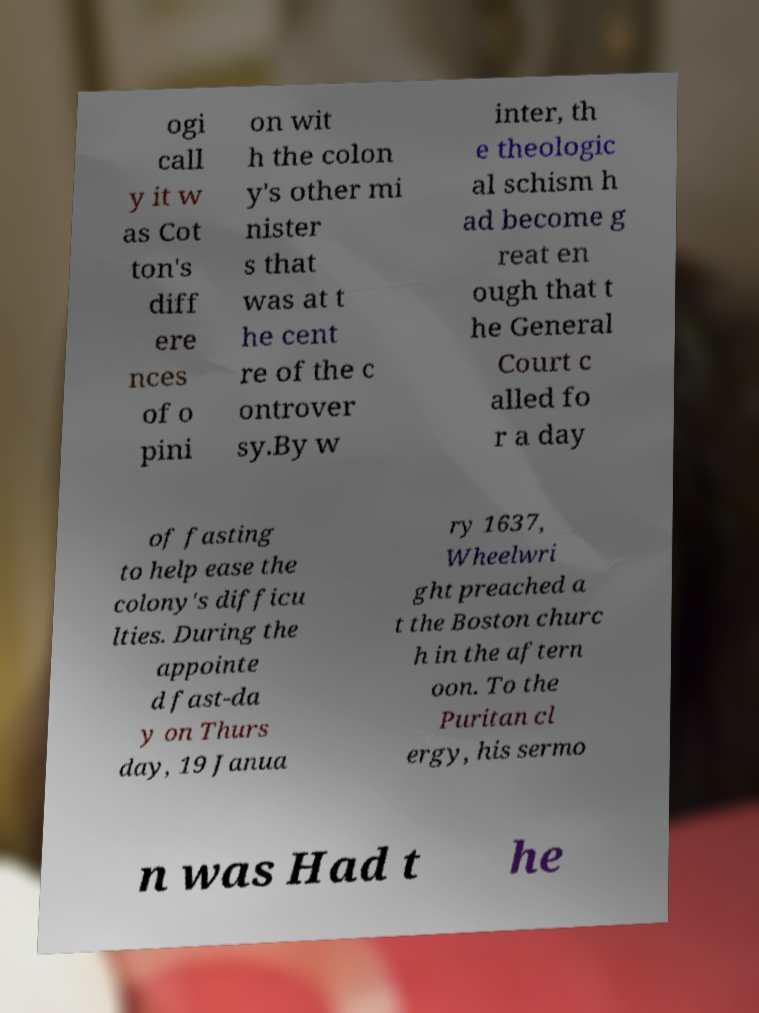What messages or text are displayed in this image? I need them in a readable, typed format. ogi call y it w as Cot ton's diff ere nces of o pini on wit h the colon y's other mi nister s that was at t he cent re of the c ontrover sy.By w inter, th e theologic al schism h ad become g reat en ough that t he General Court c alled fo r a day of fasting to help ease the colony's difficu lties. During the appointe d fast-da y on Thurs day, 19 Janua ry 1637, Wheelwri ght preached a t the Boston churc h in the aftern oon. To the Puritan cl ergy, his sermo n was Had t he 